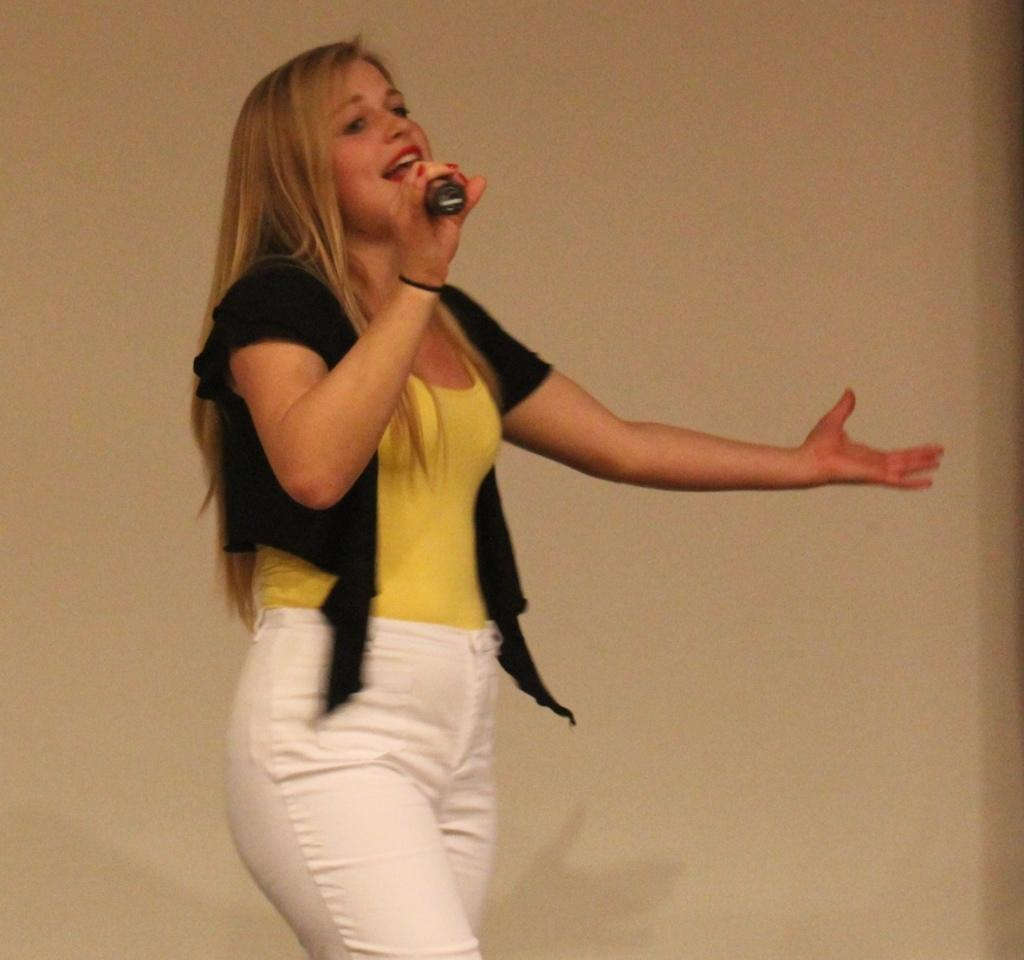Who is the main subject in the image? There is a woman in the image. What is the woman doing in the image? The woman is standing and holding a microphone. What might the woman be doing with the microphone? The woman may be singing a song. What can be seen in the background of the image? There is a wall in the background of the image. How many people are supporting the woman in the image? There is no indication in the image that the woman is being supported by anyone. What type of group is the woman a part of in the image? There is no group visible in the image, and the woman's affiliation is not mentioned. 